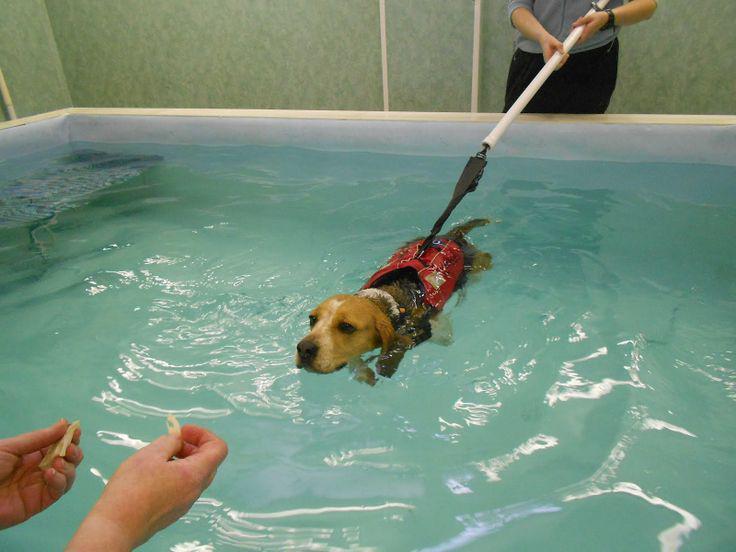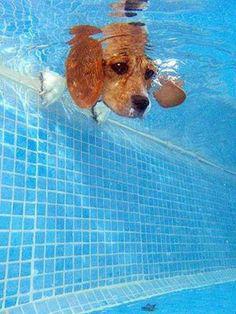The first image is the image on the left, the second image is the image on the right. Examine the images to the left and right. Is the description "There are two beagles swimming and both of them have their heads above water." accurate? Answer yes or no. No. The first image is the image on the left, the second image is the image on the right. For the images displayed, is the sentence "Dogs are swimming in an outdoor swimming pool." factually correct? Answer yes or no. No. 